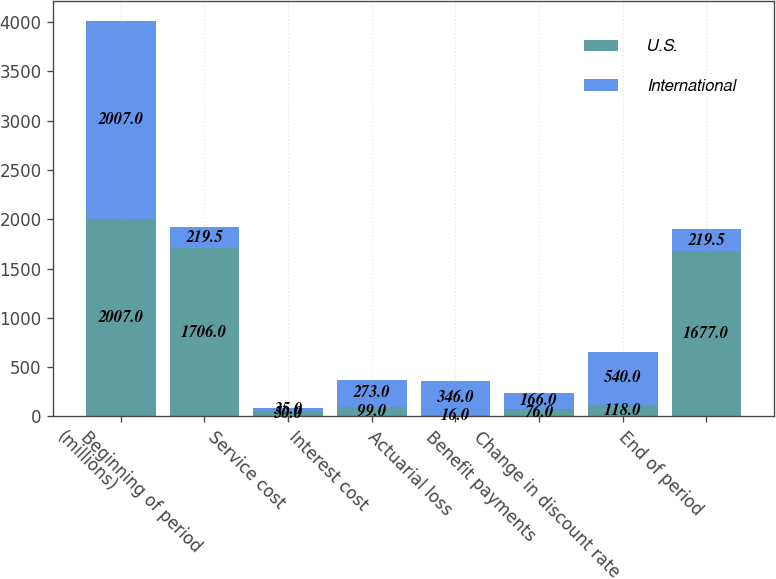<chart> <loc_0><loc_0><loc_500><loc_500><stacked_bar_chart><ecel><fcel>(millions)<fcel>Beginning of period<fcel>Service cost<fcel>Interest cost<fcel>Actuarial loss<fcel>Benefit payments<fcel>Change in discount rate<fcel>End of period<nl><fcel>U.S.<fcel>2007<fcel>1706<fcel>50<fcel>99<fcel>16<fcel>76<fcel>118<fcel>1677<nl><fcel>International<fcel>2007<fcel>219.5<fcel>35<fcel>273<fcel>346<fcel>166<fcel>540<fcel>219.5<nl></chart> 